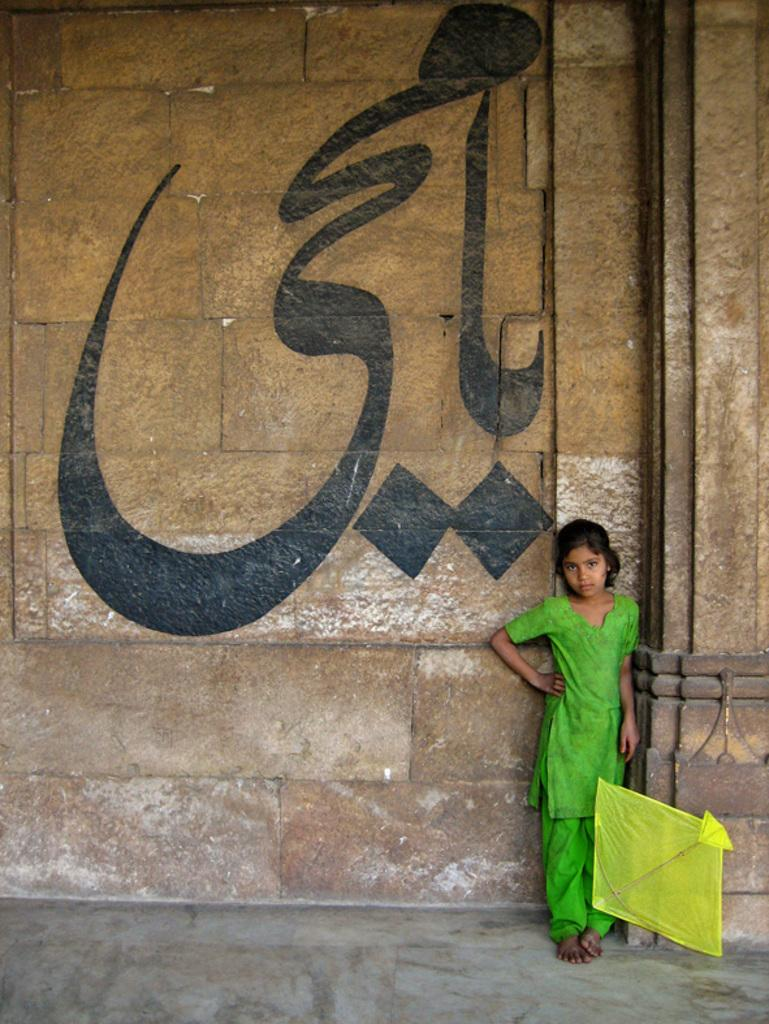Who is present in the image? There is a girl in the image. What is the girl's position in relation to the wall? The girl is standing near a wall. What object can be seen in the image besides the girl? There is a yellow kite in the image. Where is the nearest store to the girl in the image? There is no information about a store or its location in the image. What type of fruit is the girl holding in the image? There is no fruit, including quince, present in the image. 